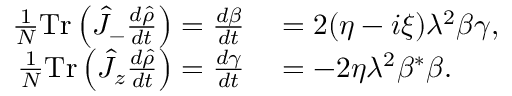<formula> <loc_0><loc_0><loc_500><loc_500>\begin{array} { r l } { \frac { 1 } { N } T r \left ( \hat { J } _ { - } \frac { d \hat { \rho } } { d t } \right ) = \frac { d \beta } { d t } } & = 2 ( \eta - i \xi ) \lambda ^ { 2 } \beta \gamma , } \\ { \frac { 1 } { N } T r \left ( \hat { J } _ { z } \frac { d \hat { \rho } } { d t } \right ) = \frac { d \gamma } { d t } } & = - 2 \eta \lambda ^ { 2 } \beta ^ { * } \beta . } \end{array}</formula> 